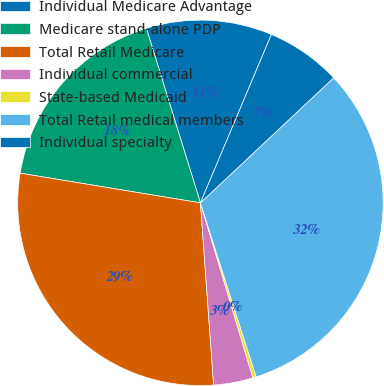Convert chart. <chart><loc_0><loc_0><loc_500><loc_500><pie_chart><fcel>Individual Medicare Advantage<fcel>Medicare stand-alone PDP<fcel>Total Retail Medicare<fcel>Individual commercial<fcel>State-based Medicaid<fcel>Total Retail medical members<fcel>Individual specialty<nl><fcel>11.13%<fcel>17.62%<fcel>28.75%<fcel>3.48%<fcel>0.3%<fcel>32.06%<fcel>6.65%<nl></chart> 